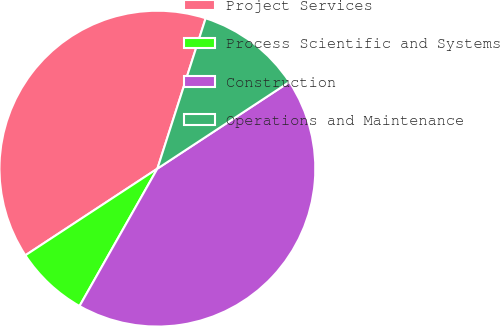<chart> <loc_0><loc_0><loc_500><loc_500><pie_chart><fcel>Project Services<fcel>Process Scientific and Systems<fcel>Construction<fcel>Operations and Maintenance<nl><fcel>39.19%<fcel>7.55%<fcel>42.45%<fcel>10.81%<nl></chart> 